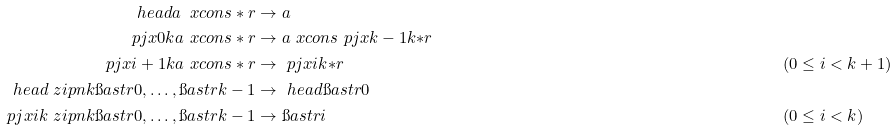Convert formula to latex. <formula><loc_0><loc_0><loc_500><loc_500>\ h e a d { a \ x c o n s \ast r } & \to a \\ \ p j x { 0 } { k } { a \ x c o n s \ast r } & \to a \ x c o n s \ p j x { k - 1 } { k } { \ast r } \\ \ p j x { i + 1 } { k } { a \ x c o n s \ast r } & \to \ p j x { i } { k } { \ast r } & & ( 0 \leq i < k + 1 ) \\ \ h e a d { \ z i p n { k } { \i a s t r { 0 } , \dots , \i a s t r { k - 1 } } } & \to \ h e a d { \i a s t r { 0 } } \\ \ p j x { i } { k } { \ z i p n { k } { \i a s t r { 0 } , \dots , \i a s t r { k - 1 } } } & \to \i a s t r { i } & & ( 0 \leq i < k )</formula> 